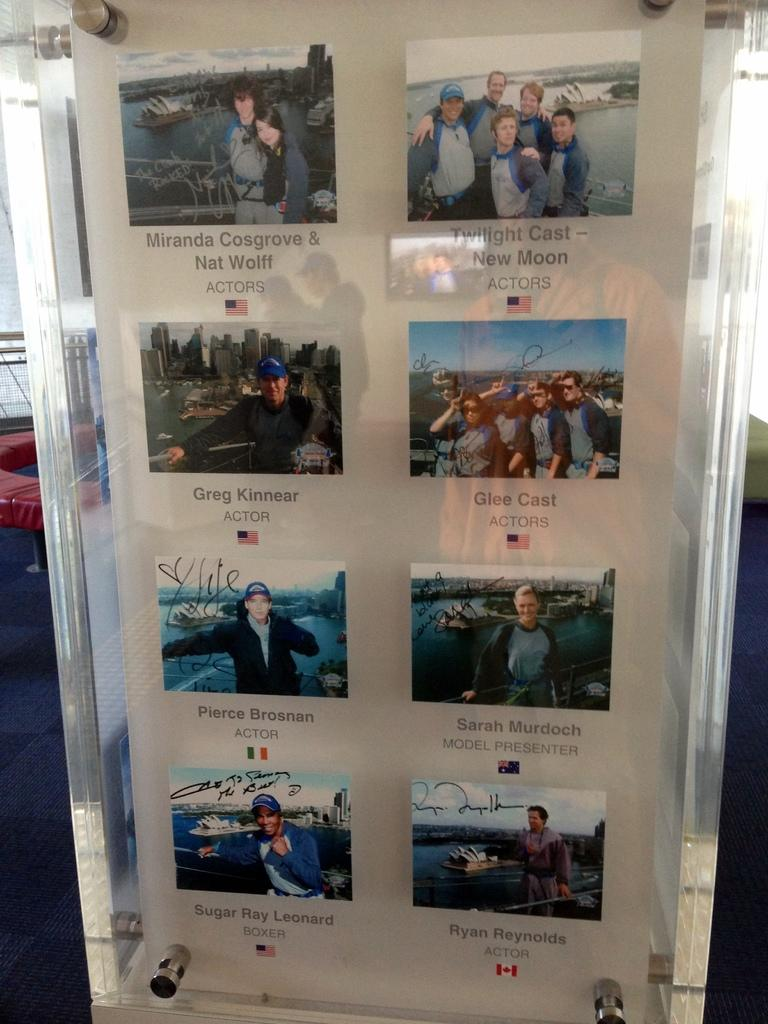<image>
Summarize the visual content of the image. Pierce Brosnan is pictured over a flag of Ireland 